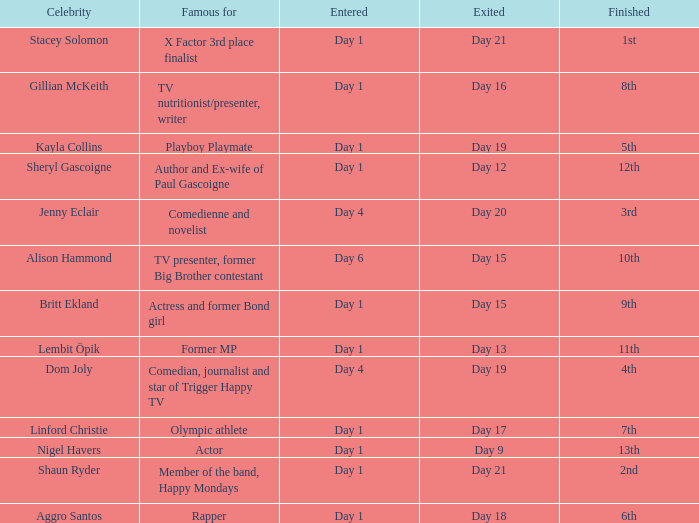Could you help me parse every detail presented in this table? {'header': ['Celebrity', 'Famous for', 'Entered', 'Exited', 'Finished'], 'rows': [['Stacey Solomon', 'X Factor 3rd place finalist', 'Day 1', 'Day 21', '1st'], ['Gillian McKeith', 'TV nutritionist/presenter, writer', 'Day 1', 'Day 16', '8th'], ['Kayla Collins', 'Playboy Playmate', 'Day 1', 'Day 19', '5th'], ['Sheryl Gascoigne', 'Author and Ex-wife of Paul Gascoigne', 'Day 1', 'Day 12', '12th'], ['Jenny Eclair', 'Comedienne and novelist', 'Day 4', 'Day 20', '3rd'], ['Alison Hammond', 'TV presenter, former Big Brother contestant', 'Day 6', 'Day 15', '10th'], ['Britt Ekland', 'Actress and former Bond girl', 'Day 1', 'Day 15', '9th'], ['Lembit Öpik', 'Former MP', 'Day 1', 'Day 13', '11th'], ['Dom Joly', 'Comedian, journalist and star of Trigger Happy TV', 'Day 4', 'Day 19', '4th'], ['Linford Christie', 'Olympic athlete', 'Day 1', 'Day 17', '7th'], ['Nigel Havers', 'Actor', 'Day 1', 'Day 9', '13th'], ['Shaun Ryder', 'Member of the band, Happy Mondays', 'Day 1', 'Day 21', '2nd'], ['Aggro Santos', 'Rapper', 'Day 1', 'Day 18', '6th']]} Which celebrity was famous for being a rapper? Aggro Santos. 